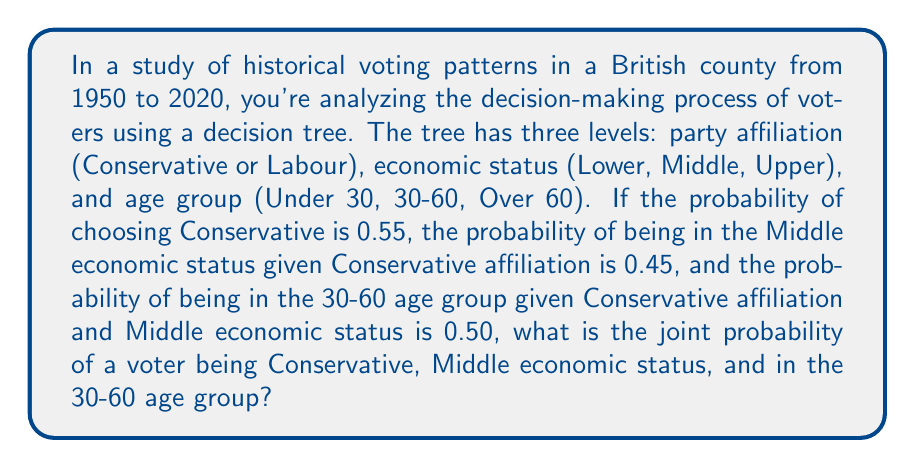What is the answer to this math problem? To solve this problem, we need to use the concept of conditional probability and the multiplication rule for joint probabilities. Let's break it down step by step:

1. Define the events:
   A: Voter chooses Conservative
   B: Voter is in Middle economic status
   C: Voter is in 30-60 age group

2. Given probabilities:
   $P(A) = 0.55$
   $P(B|A) = 0.45$
   $P(C|A \cap B) = 0.50$

3. The joint probability we're looking for is $P(A \cap B \cap C)$

4. Using the multiplication rule for joint probabilities:
   $$P(A \cap B \cap C) = P(A) \cdot P(B|A) \cdot P(C|A \cap B)$$

5. Substitute the given probabilities:
   $$P(A \cap B \cap C) = 0.55 \cdot 0.45 \cdot 0.50$$

6. Calculate the result:
   $$P(A \cap B \cap C) = 0.55 \cdot 0.45 \cdot 0.50 = 0.12375$$

Therefore, the joint probability of a voter being Conservative, Middle economic status, and in the 30-60 age group is 0.12375 or 12.375%.
Answer: 0.12375 or 12.375% 